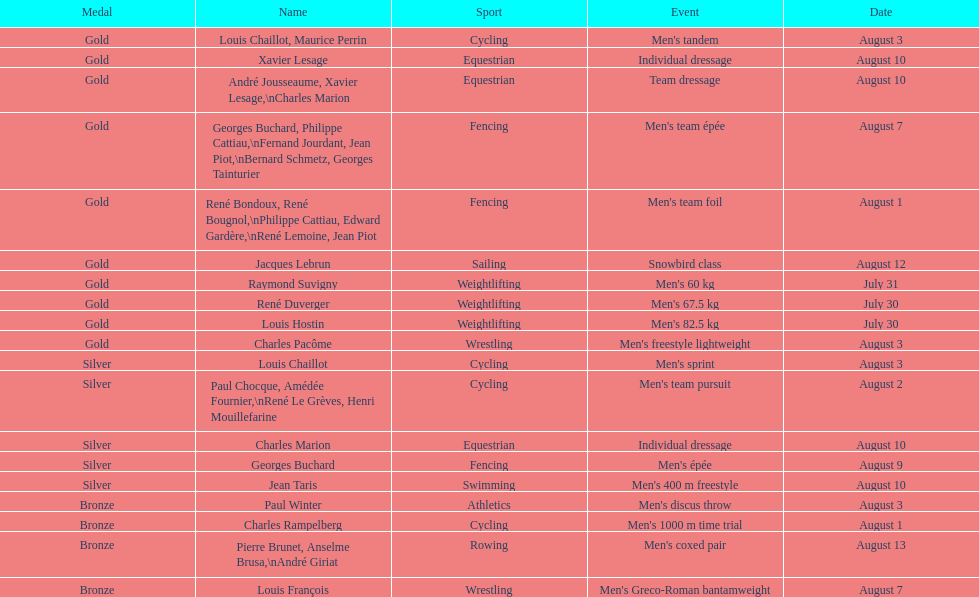Would you be able to parse every entry in this table? {'header': ['Medal', 'Name', 'Sport', 'Event', 'Date'], 'rows': [['Gold', 'Louis Chaillot, Maurice Perrin', 'Cycling', "Men's tandem", 'August 3'], ['Gold', 'Xavier Lesage', 'Equestrian', 'Individual dressage', 'August 10'], ['Gold', 'André Jousseaume, Xavier Lesage,\\nCharles Marion', 'Equestrian', 'Team dressage', 'August 10'], ['Gold', 'Georges Buchard, Philippe Cattiau,\\nFernand Jourdant, Jean Piot,\\nBernard Schmetz, Georges Tainturier', 'Fencing', "Men's team épée", 'August 7'], ['Gold', 'René Bondoux, René Bougnol,\\nPhilippe Cattiau, Edward Gardère,\\nRené Lemoine, Jean Piot', 'Fencing', "Men's team foil", 'August 1'], ['Gold', 'Jacques Lebrun', 'Sailing', 'Snowbird class', 'August 12'], ['Gold', 'Raymond Suvigny', 'Weightlifting', "Men's 60 kg", 'July 31'], ['Gold', 'René Duverger', 'Weightlifting', "Men's 67.5 kg", 'July 30'], ['Gold', 'Louis Hostin', 'Weightlifting', "Men's 82.5 kg", 'July 30'], ['Gold', 'Charles Pacôme', 'Wrestling', "Men's freestyle lightweight", 'August 3'], ['Silver', 'Louis Chaillot', 'Cycling', "Men's sprint", 'August 3'], ['Silver', 'Paul Chocque, Amédée Fournier,\\nRené Le Grèves, Henri Mouillefarine', 'Cycling', "Men's team pursuit", 'August 2'], ['Silver', 'Charles Marion', 'Equestrian', 'Individual dressage', 'August 10'], ['Silver', 'Georges Buchard', 'Fencing', "Men's épée", 'August 9'], ['Silver', 'Jean Taris', 'Swimming', "Men's 400 m freestyle", 'August 10'], ['Bronze', 'Paul Winter', 'Athletics', "Men's discus throw", 'August 3'], ['Bronze', 'Charles Rampelberg', 'Cycling', "Men's 1000 m time trial", 'August 1'], ['Bronze', 'Pierre Brunet, Anselme Brusa,\\nAndré Giriat', 'Rowing', "Men's coxed pair", 'August 13'], ['Bronze', 'Louis François', 'Wrestling', "Men's Greco-Roman bantamweight", 'August 7']]} After august 3, how many medals have been secured? 9. 